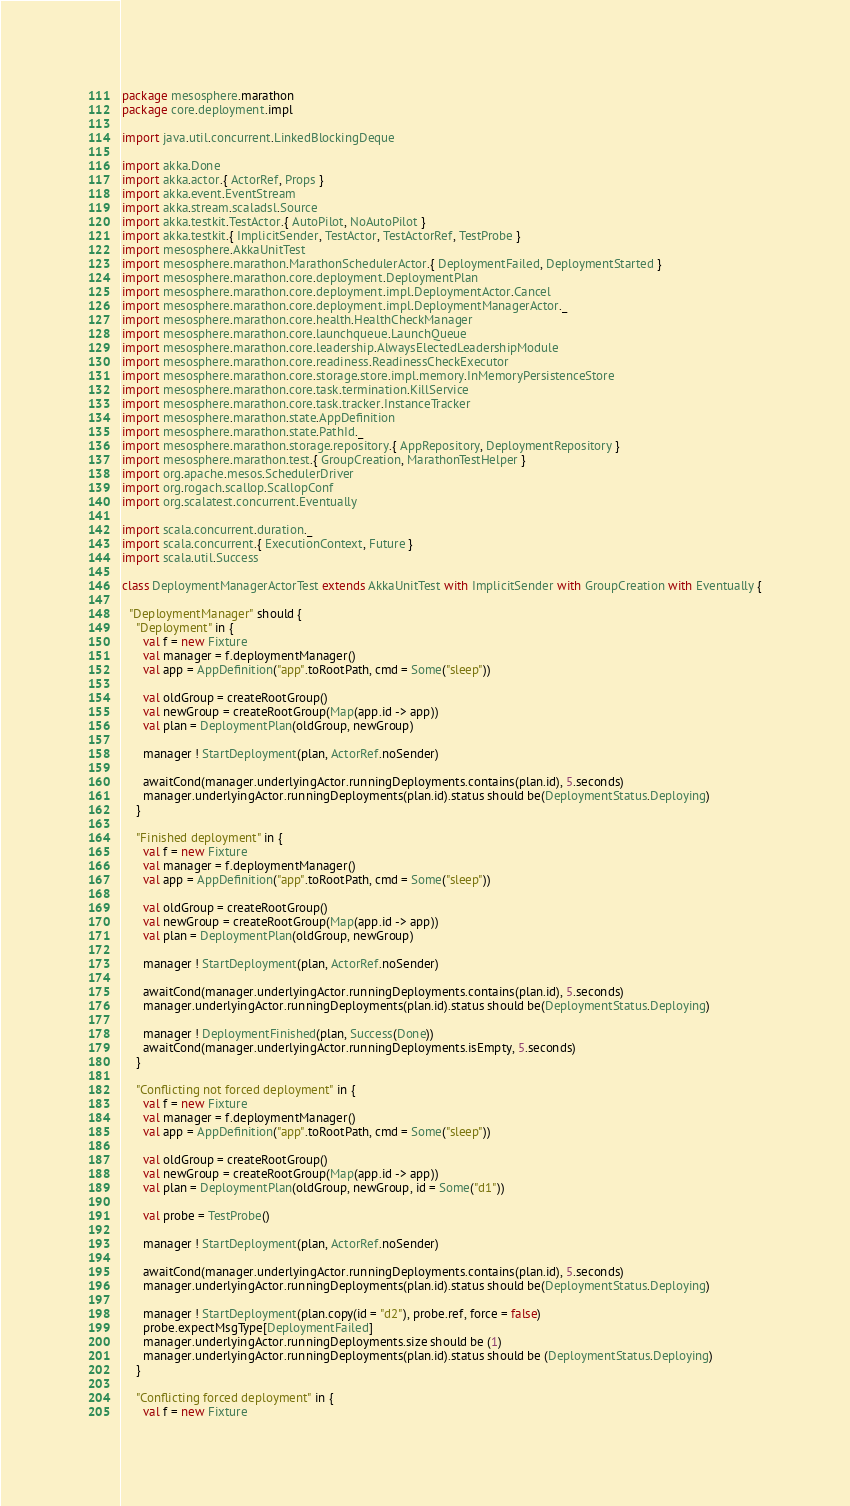Convert code to text. <code><loc_0><loc_0><loc_500><loc_500><_Scala_>package mesosphere.marathon
package core.deployment.impl

import java.util.concurrent.LinkedBlockingDeque

import akka.Done
import akka.actor.{ ActorRef, Props }
import akka.event.EventStream
import akka.stream.scaladsl.Source
import akka.testkit.TestActor.{ AutoPilot, NoAutoPilot }
import akka.testkit.{ ImplicitSender, TestActor, TestActorRef, TestProbe }
import mesosphere.AkkaUnitTest
import mesosphere.marathon.MarathonSchedulerActor.{ DeploymentFailed, DeploymentStarted }
import mesosphere.marathon.core.deployment.DeploymentPlan
import mesosphere.marathon.core.deployment.impl.DeploymentActor.Cancel
import mesosphere.marathon.core.deployment.impl.DeploymentManagerActor._
import mesosphere.marathon.core.health.HealthCheckManager
import mesosphere.marathon.core.launchqueue.LaunchQueue
import mesosphere.marathon.core.leadership.AlwaysElectedLeadershipModule
import mesosphere.marathon.core.readiness.ReadinessCheckExecutor
import mesosphere.marathon.core.storage.store.impl.memory.InMemoryPersistenceStore
import mesosphere.marathon.core.task.termination.KillService
import mesosphere.marathon.core.task.tracker.InstanceTracker
import mesosphere.marathon.state.AppDefinition
import mesosphere.marathon.state.PathId._
import mesosphere.marathon.storage.repository.{ AppRepository, DeploymentRepository }
import mesosphere.marathon.test.{ GroupCreation, MarathonTestHelper }
import org.apache.mesos.SchedulerDriver
import org.rogach.scallop.ScallopConf
import org.scalatest.concurrent.Eventually

import scala.concurrent.duration._
import scala.concurrent.{ ExecutionContext, Future }
import scala.util.Success

class DeploymentManagerActorTest extends AkkaUnitTest with ImplicitSender with GroupCreation with Eventually {

  "DeploymentManager" should {
    "Deployment" in {
      val f = new Fixture
      val manager = f.deploymentManager()
      val app = AppDefinition("app".toRootPath, cmd = Some("sleep"))

      val oldGroup = createRootGroup()
      val newGroup = createRootGroup(Map(app.id -> app))
      val plan = DeploymentPlan(oldGroup, newGroup)

      manager ! StartDeployment(plan, ActorRef.noSender)

      awaitCond(manager.underlyingActor.runningDeployments.contains(plan.id), 5.seconds)
      manager.underlyingActor.runningDeployments(plan.id).status should be(DeploymentStatus.Deploying)
    }

    "Finished deployment" in {
      val f = new Fixture
      val manager = f.deploymentManager()
      val app = AppDefinition("app".toRootPath, cmd = Some("sleep"))

      val oldGroup = createRootGroup()
      val newGroup = createRootGroup(Map(app.id -> app))
      val plan = DeploymentPlan(oldGroup, newGroup)

      manager ! StartDeployment(plan, ActorRef.noSender)

      awaitCond(manager.underlyingActor.runningDeployments.contains(plan.id), 5.seconds)
      manager.underlyingActor.runningDeployments(plan.id).status should be(DeploymentStatus.Deploying)

      manager ! DeploymentFinished(plan, Success(Done))
      awaitCond(manager.underlyingActor.runningDeployments.isEmpty, 5.seconds)
    }

    "Conflicting not forced deployment" in {
      val f = new Fixture
      val manager = f.deploymentManager()
      val app = AppDefinition("app".toRootPath, cmd = Some("sleep"))

      val oldGroup = createRootGroup()
      val newGroup = createRootGroup(Map(app.id -> app))
      val plan = DeploymentPlan(oldGroup, newGroup, id = Some("d1"))

      val probe = TestProbe()

      manager ! StartDeployment(plan, ActorRef.noSender)

      awaitCond(manager.underlyingActor.runningDeployments.contains(plan.id), 5.seconds)
      manager.underlyingActor.runningDeployments(plan.id).status should be(DeploymentStatus.Deploying)

      manager ! StartDeployment(plan.copy(id = "d2"), probe.ref, force = false)
      probe.expectMsgType[DeploymentFailed]
      manager.underlyingActor.runningDeployments.size should be (1)
      manager.underlyingActor.runningDeployments(plan.id).status should be (DeploymentStatus.Deploying)
    }

    "Conflicting forced deployment" in {
      val f = new Fixture</code> 